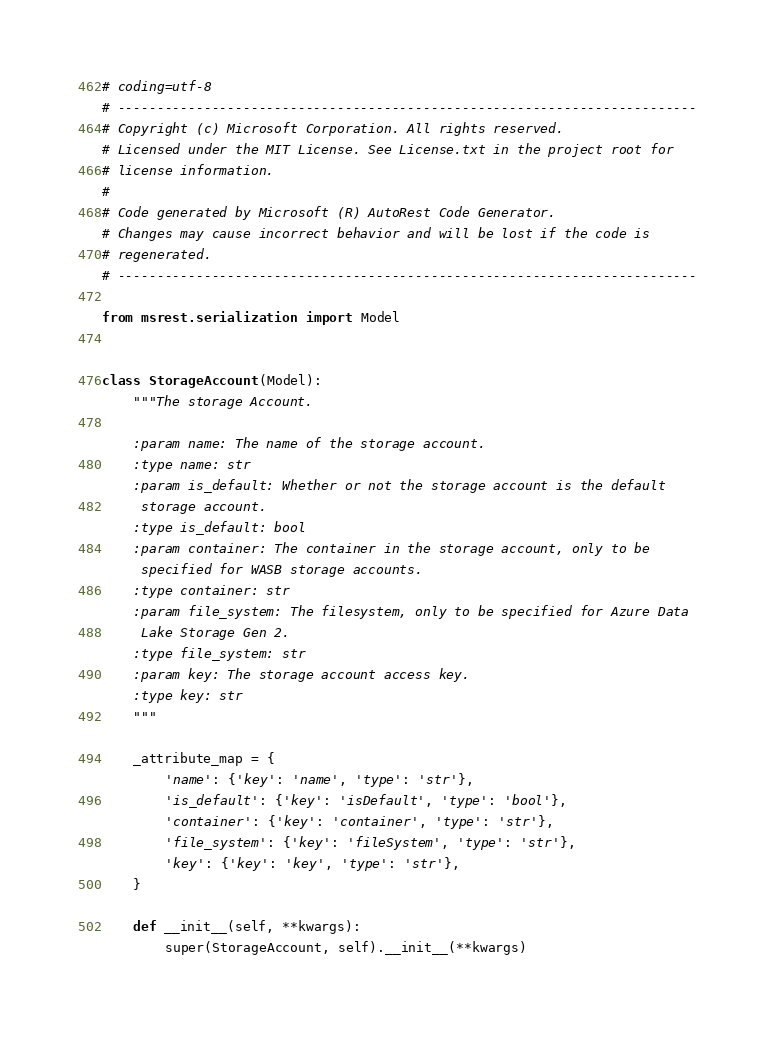<code> <loc_0><loc_0><loc_500><loc_500><_Python_># coding=utf-8
# --------------------------------------------------------------------------
# Copyright (c) Microsoft Corporation. All rights reserved.
# Licensed under the MIT License. See License.txt in the project root for
# license information.
#
# Code generated by Microsoft (R) AutoRest Code Generator.
# Changes may cause incorrect behavior and will be lost if the code is
# regenerated.
# --------------------------------------------------------------------------

from msrest.serialization import Model


class StorageAccount(Model):
    """The storage Account.

    :param name: The name of the storage account.
    :type name: str
    :param is_default: Whether or not the storage account is the default
     storage account.
    :type is_default: bool
    :param container: The container in the storage account, only to be
     specified for WASB storage accounts.
    :type container: str
    :param file_system: The filesystem, only to be specified for Azure Data
     Lake Storage Gen 2.
    :type file_system: str
    :param key: The storage account access key.
    :type key: str
    """

    _attribute_map = {
        'name': {'key': 'name', 'type': 'str'},
        'is_default': {'key': 'isDefault', 'type': 'bool'},
        'container': {'key': 'container', 'type': 'str'},
        'file_system': {'key': 'fileSystem', 'type': 'str'},
        'key': {'key': 'key', 'type': 'str'},
    }

    def __init__(self, **kwargs):
        super(StorageAccount, self).__init__(**kwargs)</code> 